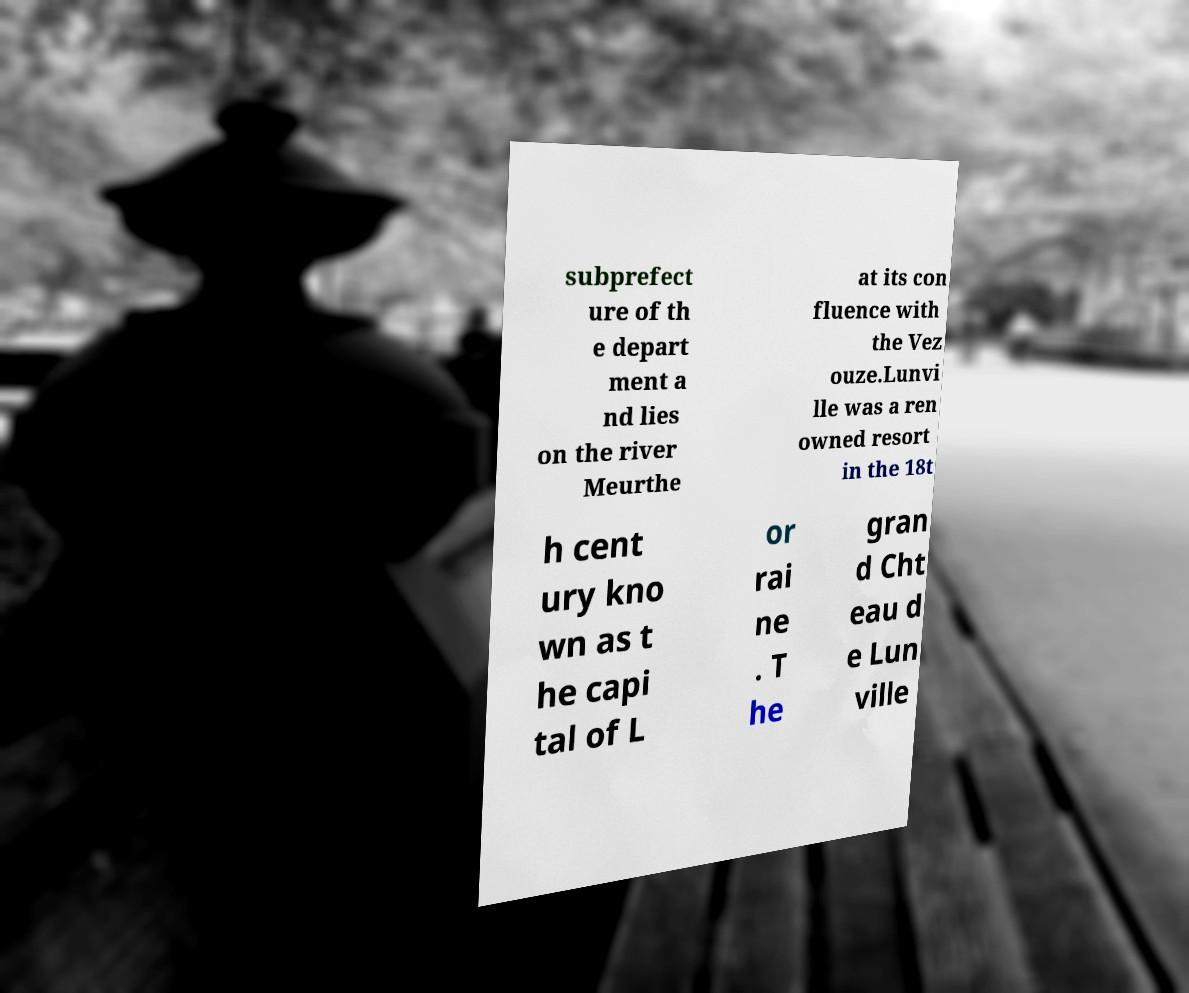For documentation purposes, I need the text within this image transcribed. Could you provide that? subprefect ure of th e depart ment a nd lies on the river Meurthe at its con fluence with the Vez ouze.Lunvi lle was a ren owned resort in the 18t h cent ury kno wn as t he capi tal of L or rai ne . T he gran d Cht eau d e Lun ville 